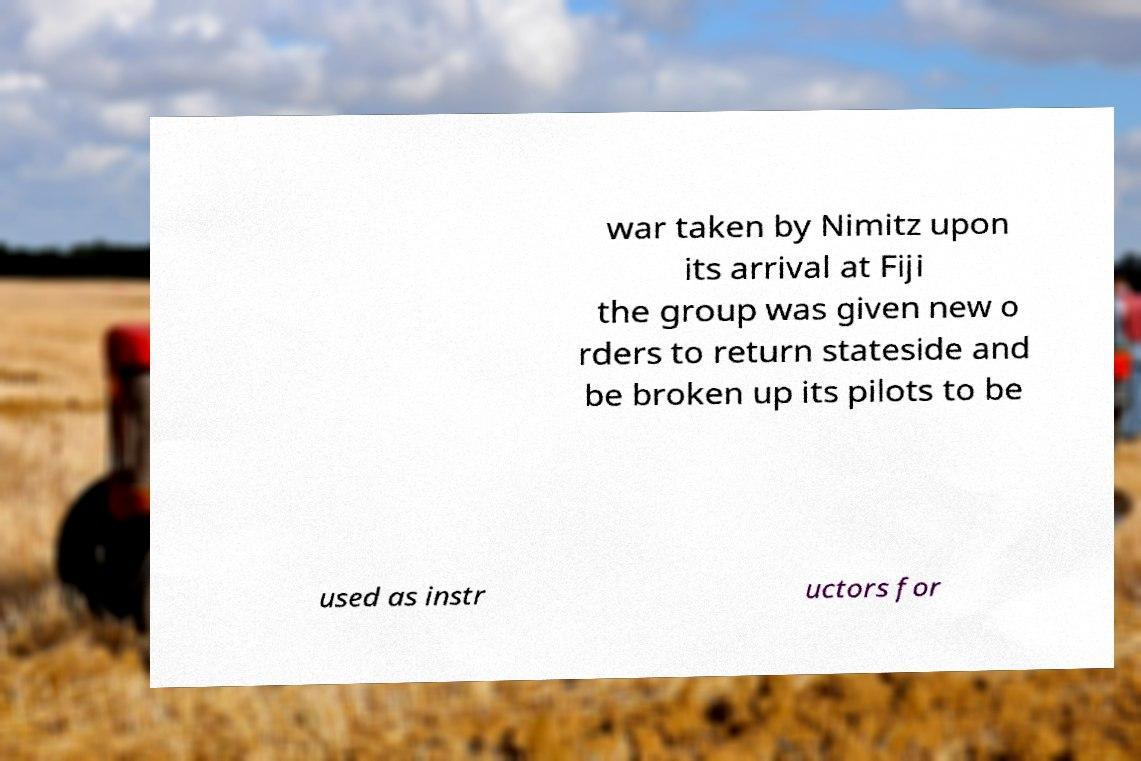Could you assist in decoding the text presented in this image and type it out clearly? war taken by Nimitz upon its arrival at Fiji the group was given new o rders to return stateside and be broken up its pilots to be used as instr uctors for 